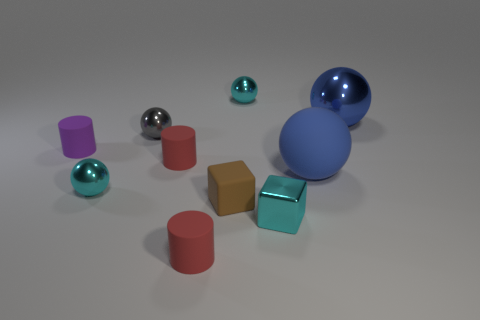What is the size of the thing that is right of the large blue rubber sphere that is in front of the purple rubber thing?
Make the answer very short. Large. There is a cyan shiny thing that is both in front of the purple rubber thing and left of the cyan block; what is its size?
Offer a very short reply. Small. How many cyan balls are the same size as the brown matte cube?
Your answer should be compact. 2. What number of matte things are either tiny blue cylinders or blue balls?
Ensure brevity in your answer.  1. What size is the metal sphere that is the same color as the big matte thing?
Your answer should be very brief. Large. What is the small cyan thing in front of the tiny cyan metal object on the left side of the small brown thing made of?
Give a very brief answer. Metal. What number of things are either gray metallic spheres or tiny cyan objects that are to the left of the cyan cube?
Your answer should be very brief. 3. What is the size of the blue thing that is made of the same material as the gray ball?
Keep it short and to the point. Large. What number of blue objects are either big objects or shiny objects?
Make the answer very short. 2. Are there any other things that have the same material as the small purple cylinder?
Your answer should be very brief. Yes. 